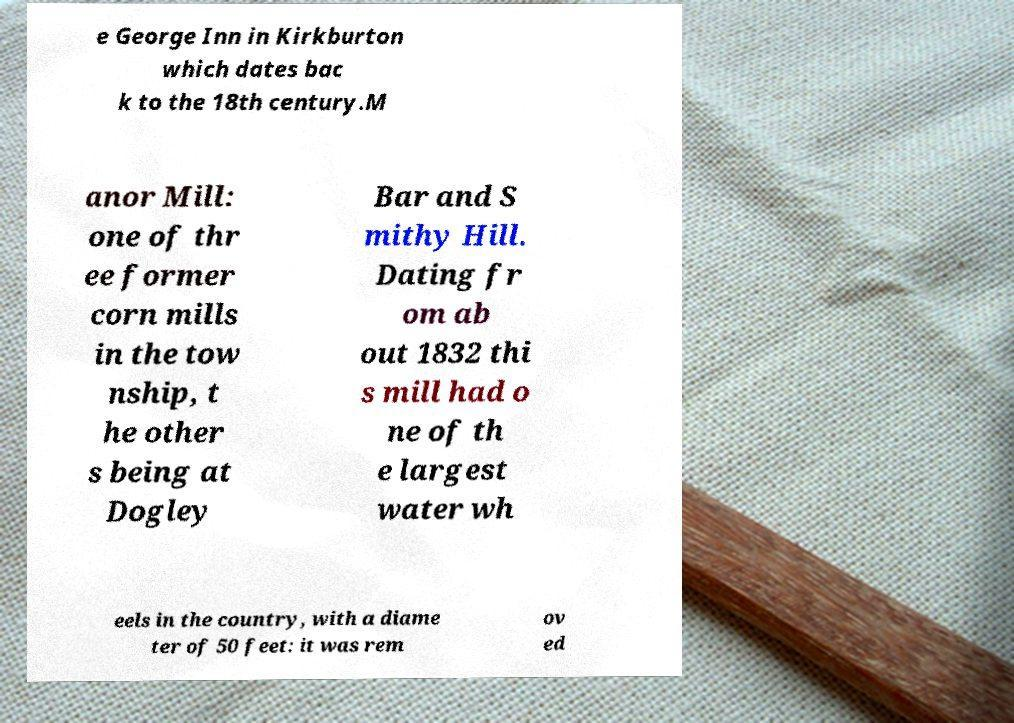For documentation purposes, I need the text within this image transcribed. Could you provide that? e George Inn in Kirkburton which dates bac k to the 18th century.M anor Mill: one of thr ee former corn mills in the tow nship, t he other s being at Dogley Bar and S mithy Hill. Dating fr om ab out 1832 thi s mill had o ne of th e largest water wh eels in the country, with a diame ter of 50 feet: it was rem ov ed 